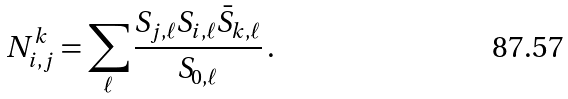Convert formula to latex. <formula><loc_0><loc_0><loc_500><loc_500>N _ { i , j } ^ { k } = \sum _ { \ell } \frac { S _ { j , \ell } S _ { i , \ell } \bar { S } _ { k , \ell } } { S _ { 0 , \ell } } \, .</formula> 